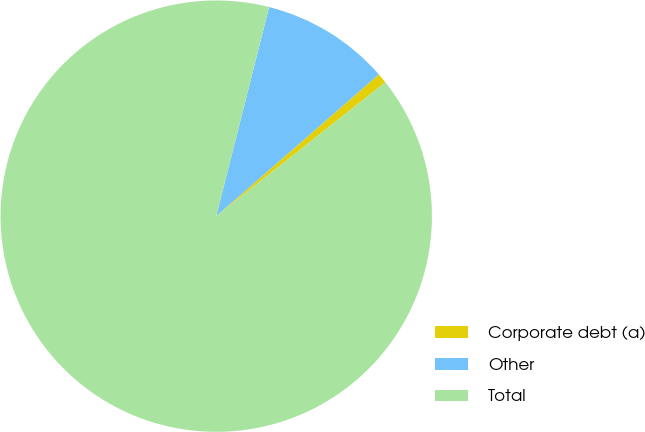Convert chart to OTSL. <chart><loc_0><loc_0><loc_500><loc_500><pie_chart><fcel>Corporate debt (a)<fcel>Other<fcel>Total<nl><fcel>0.76%<fcel>9.64%<fcel>89.6%<nl></chart> 